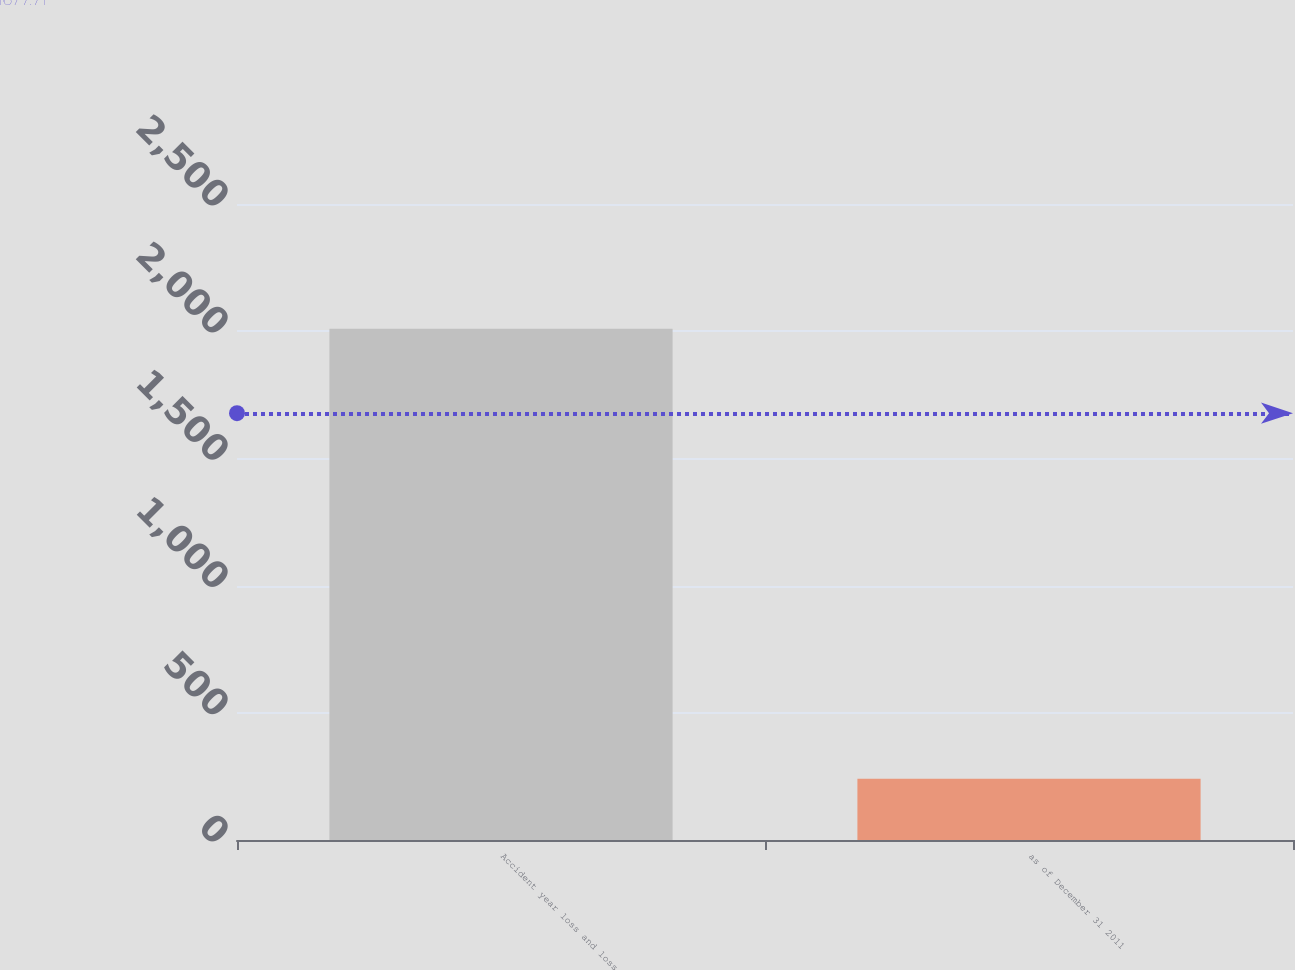Convert chart to OTSL. <chart><loc_0><loc_0><loc_500><loc_500><bar_chart><fcel>Accident year loss and loss<fcel>as of December 31 2011<nl><fcel>2010<fcel>241<nl></chart> 